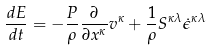<formula> <loc_0><loc_0><loc_500><loc_500>\frac { d E } { d t } = - \frac { P } { \rho } \frac { \partial } { \partial x ^ { \kappa } } v ^ { \kappa } + \frac { 1 } { \rho } S ^ { \kappa \lambda } \dot { \epsilon } ^ { \kappa \lambda }</formula> 